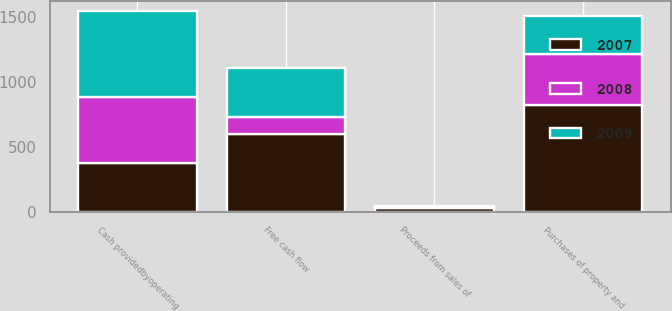Convert chart to OTSL. <chart><loc_0><loc_0><loc_500><loc_500><stacked_bar_chart><ecel><fcel>Cash providedbyoperating<fcel>Purchases of property and<fcel>Proceeds from sales of<fcel>Free cash flow<nl><fcel>2007<fcel>374.9<fcel>826.3<fcel>31.8<fcel>602<nl><fcel>2008<fcel>512.2<fcel>386.9<fcel>8.2<fcel>133.5<nl><fcel>2009<fcel>661.3<fcel>292.5<fcel>6.1<fcel>374.9<nl></chart> 